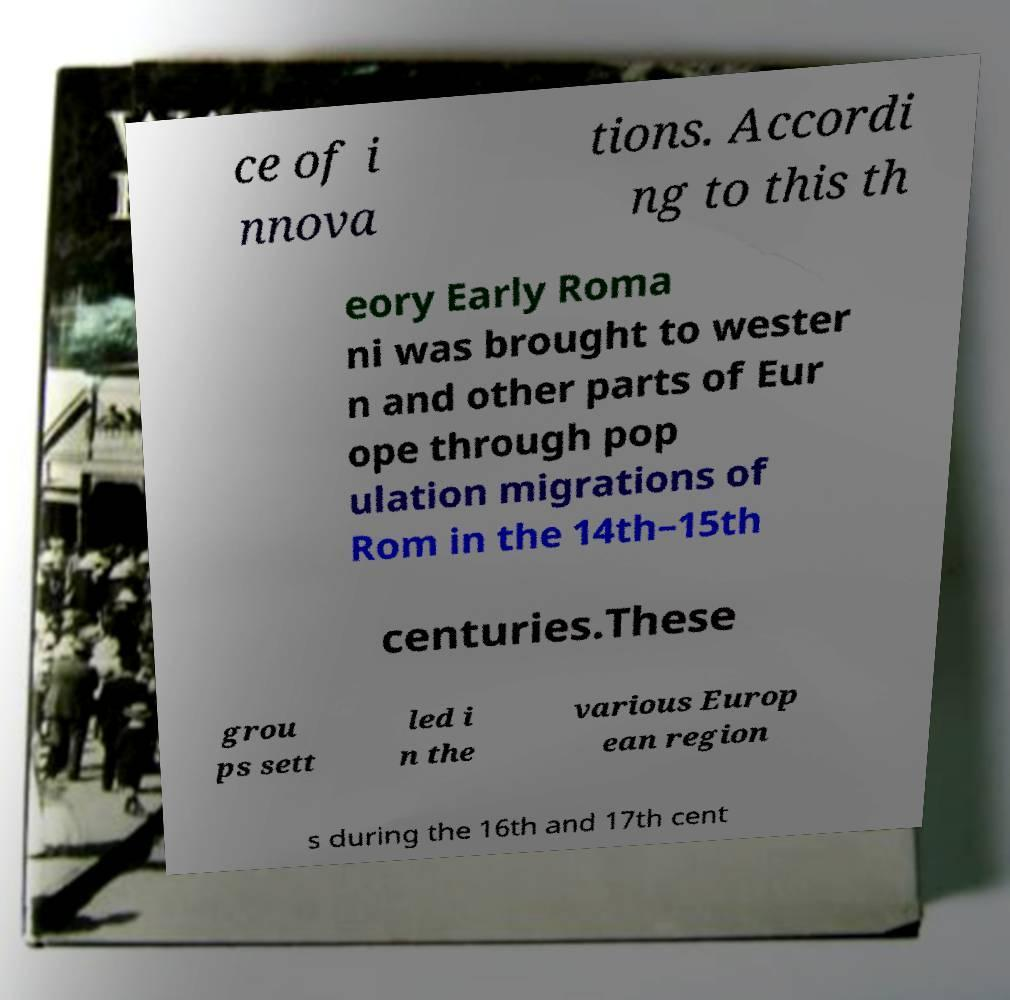For documentation purposes, I need the text within this image transcribed. Could you provide that? ce of i nnova tions. Accordi ng to this th eory Early Roma ni was brought to wester n and other parts of Eur ope through pop ulation migrations of Rom in the 14th–15th centuries.These grou ps sett led i n the various Europ ean region s during the 16th and 17th cent 